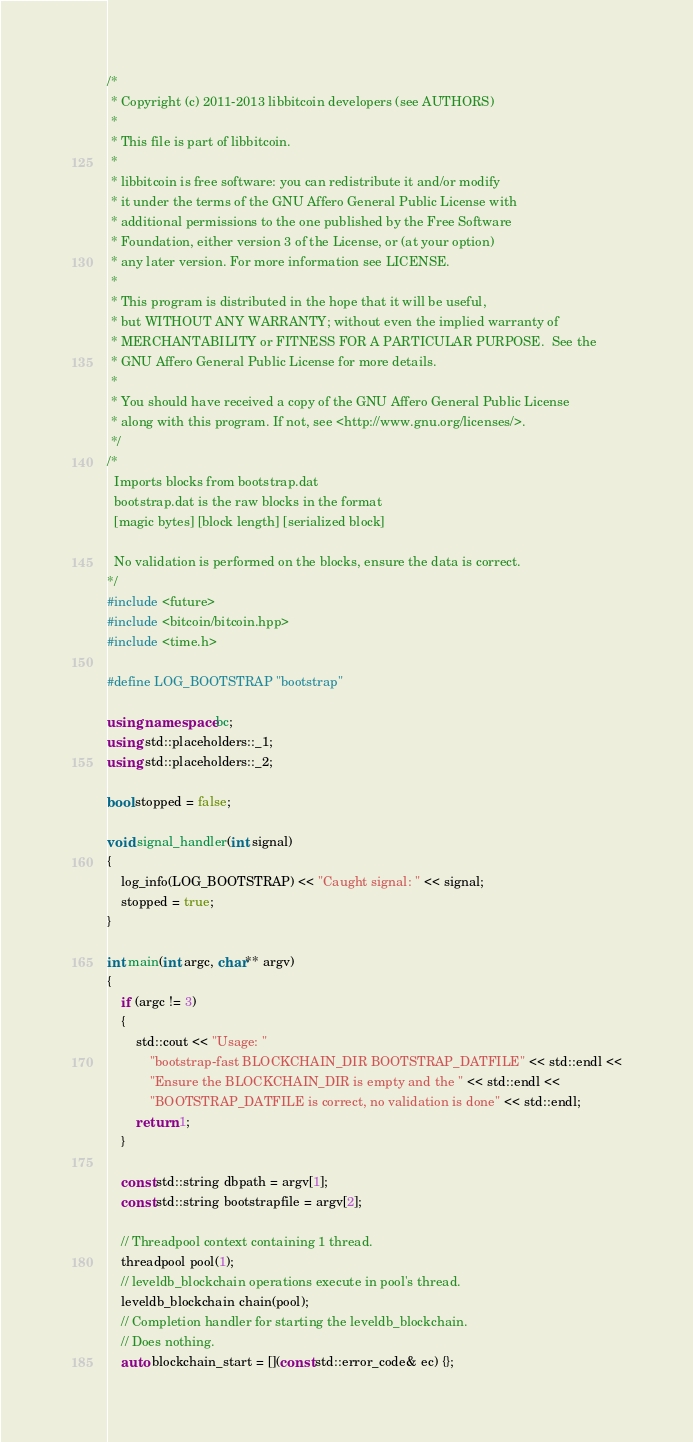<code> <loc_0><loc_0><loc_500><loc_500><_C++_>/*
 * Copyright (c) 2011-2013 libbitcoin developers (see AUTHORS)
 *
 * This file is part of libbitcoin.
 *
 * libbitcoin is free software: you can redistribute it and/or modify
 * it under the terms of the GNU Affero General Public License with
 * additional permissions to the one published by the Free Software
 * Foundation, either version 3 of the License, or (at your option) 
 * any later version. For more information see LICENSE.
 *
 * This program is distributed in the hope that it will be useful,
 * but WITHOUT ANY WARRANTY; without even the implied warranty of
 * MERCHANTABILITY or FITNESS FOR A PARTICULAR PURPOSE.  See the
 * GNU Affero General Public License for more details.
 *
 * You should have received a copy of the GNU Affero General Public License
 * along with this program. If not, see <http://www.gnu.org/licenses/>.
 */
/*
  Imports blocks from bootstrap.dat
  bootstrap.dat is the raw blocks in the format
  [magic bytes] [block length] [serialized block]

  No validation is performed on the blocks, ensure the data is correct.
*/
#include <future>
#include <bitcoin/bitcoin.hpp>
#include <time.h>

#define LOG_BOOTSTRAP "bootstrap"

using namespace bc;
using std::placeholders::_1;
using std::placeholders::_2;

bool stopped = false;

void signal_handler(int signal)
{
    log_info(LOG_BOOTSTRAP) << "Caught signal: " << signal;
    stopped = true;
}

int main(int argc, char** argv)
{
    if (argc != 3)
    {
        std::cout << "Usage: "
            "bootstrap-fast BLOCKCHAIN_DIR BOOTSTRAP_DATFILE" << std::endl <<
            "Ensure the BLOCKCHAIN_DIR is empty and the " << std::endl <<
            "BOOTSTRAP_DATFILE is correct, no validation is done" << std::endl;
        return 1;
    }

    const std::string dbpath = argv[1];
    const std::string bootstrapfile = argv[2];

    // Threadpool context containing 1 thread.
    threadpool pool(1);
    // leveldb_blockchain operations execute in pool's thread.
    leveldb_blockchain chain(pool);
    // Completion handler for starting the leveldb_blockchain.
    // Does nothing.
    auto blockchain_start = [](const std::error_code& ec) {};</code> 